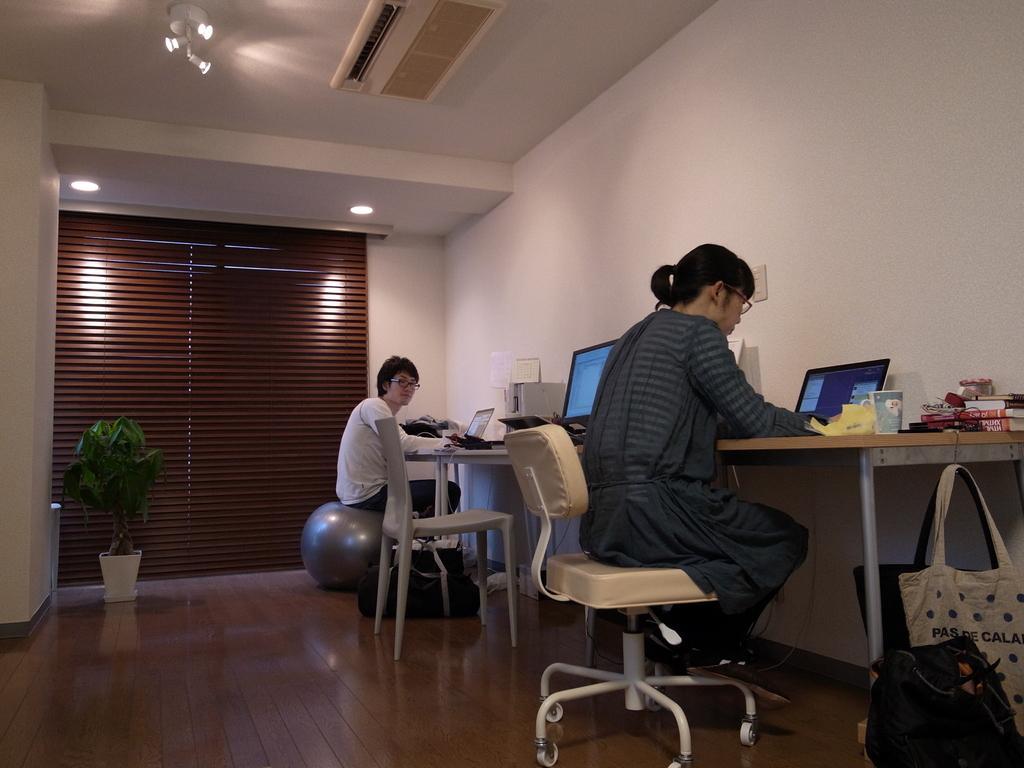Please provide a concise description of this image. In this image I can see two women are sitting where one is sitting on a chair and another one is sitting on a bean bag. On this table I can see few laptops and a monitor. I can also see few bags and a plant. 